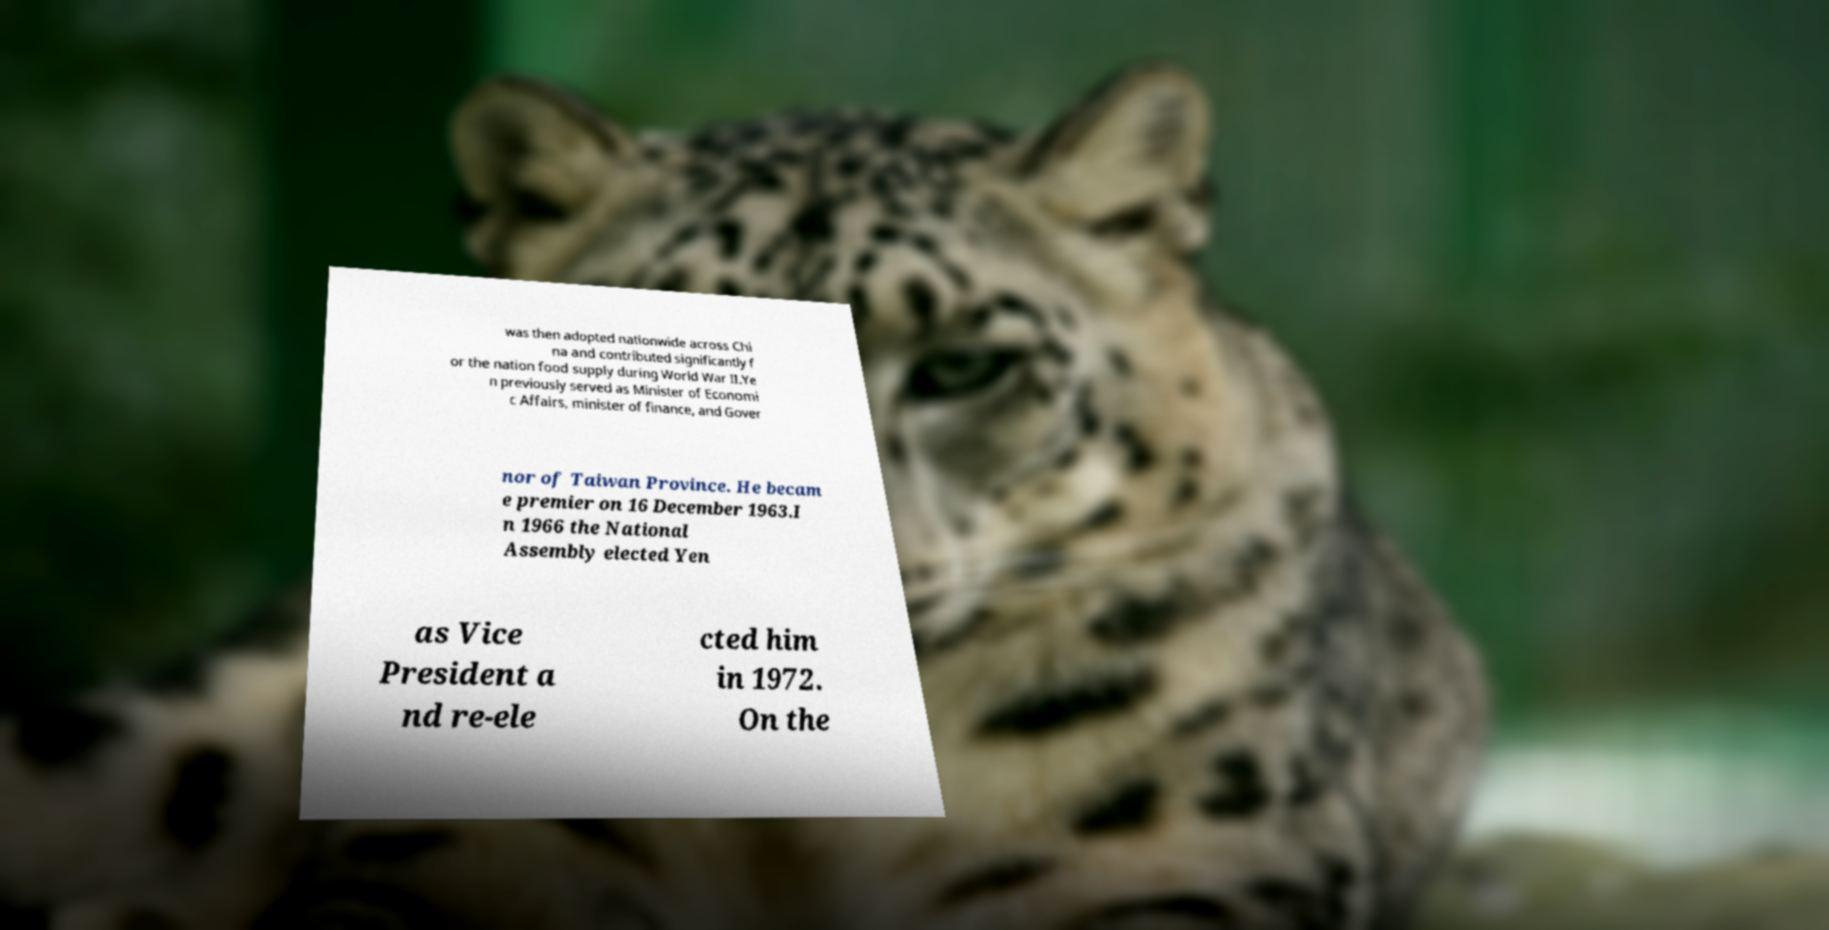For documentation purposes, I need the text within this image transcribed. Could you provide that? was then adopted nationwide across Chi na and contributed significantly f or the nation food supply during World War II.Ye n previously served as Minister of Economi c Affairs, minister of finance, and Gover nor of Taiwan Province. He becam e premier on 16 December 1963.I n 1966 the National Assembly elected Yen as Vice President a nd re-ele cted him in 1972. On the 